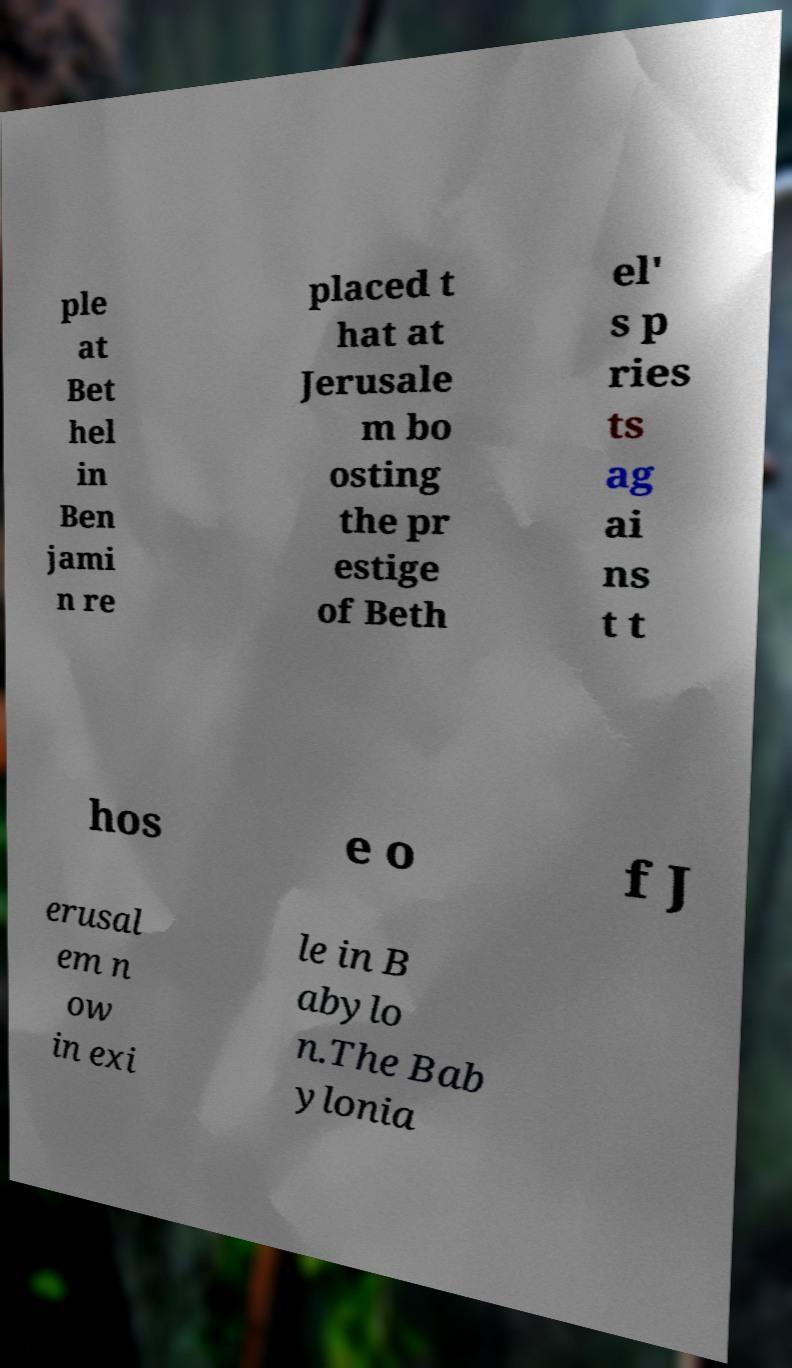Can you accurately transcribe the text from the provided image for me? ple at Bet hel in Ben jami n re placed t hat at Jerusale m bo osting the pr estige of Beth el' s p ries ts ag ai ns t t hos e o f J erusal em n ow in exi le in B abylo n.The Bab ylonia 